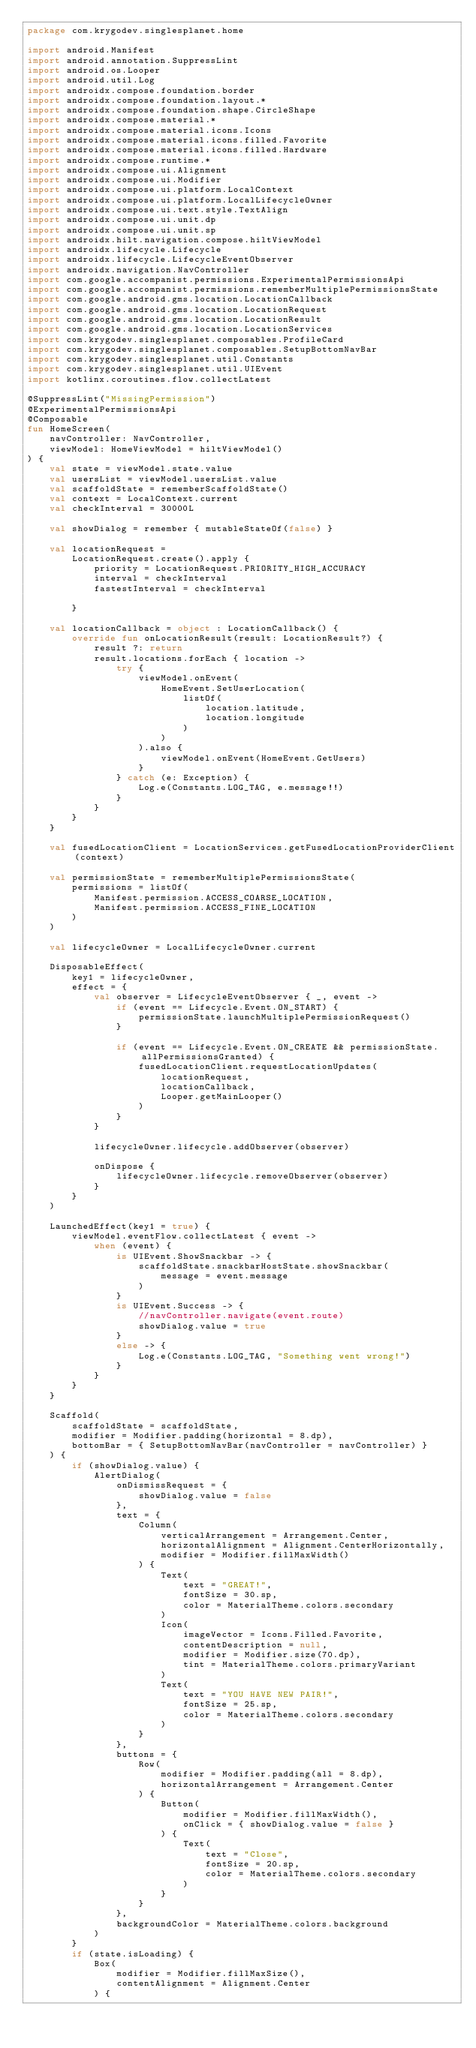Convert code to text. <code><loc_0><loc_0><loc_500><loc_500><_Kotlin_>package com.krygodev.singlesplanet.home

import android.Manifest
import android.annotation.SuppressLint
import android.os.Looper
import android.util.Log
import androidx.compose.foundation.border
import androidx.compose.foundation.layout.*
import androidx.compose.foundation.shape.CircleShape
import androidx.compose.material.*
import androidx.compose.material.icons.Icons
import androidx.compose.material.icons.filled.Favorite
import androidx.compose.material.icons.filled.Hardware
import androidx.compose.runtime.*
import androidx.compose.ui.Alignment
import androidx.compose.ui.Modifier
import androidx.compose.ui.platform.LocalContext
import androidx.compose.ui.platform.LocalLifecycleOwner
import androidx.compose.ui.text.style.TextAlign
import androidx.compose.ui.unit.dp
import androidx.compose.ui.unit.sp
import androidx.hilt.navigation.compose.hiltViewModel
import androidx.lifecycle.Lifecycle
import androidx.lifecycle.LifecycleEventObserver
import androidx.navigation.NavController
import com.google.accompanist.permissions.ExperimentalPermissionsApi
import com.google.accompanist.permissions.rememberMultiplePermissionsState
import com.google.android.gms.location.LocationCallback
import com.google.android.gms.location.LocationRequest
import com.google.android.gms.location.LocationResult
import com.google.android.gms.location.LocationServices
import com.krygodev.singlesplanet.composables.ProfileCard
import com.krygodev.singlesplanet.composables.SetupBottomNavBar
import com.krygodev.singlesplanet.util.Constants
import com.krygodev.singlesplanet.util.UIEvent
import kotlinx.coroutines.flow.collectLatest

@SuppressLint("MissingPermission")
@ExperimentalPermissionsApi
@Composable
fun HomeScreen(
    navController: NavController,
    viewModel: HomeViewModel = hiltViewModel()
) {
    val state = viewModel.state.value
    val usersList = viewModel.usersList.value
    val scaffoldState = rememberScaffoldState()
    val context = LocalContext.current
    val checkInterval = 30000L

    val showDialog = remember { mutableStateOf(false) }

    val locationRequest =
        LocationRequest.create().apply {
            priority = LocationRequest.PRIORITY_HIGH_ACCURACY
            interval = checkInterval
            fastestInterval = checkInterval

        }

    val locationCallback = object : LocationCallback() {
        override fun onLocationResult(result: LocationResult?) {
            result ?: return
            result.locations.forEach { location ->
                try {
                    viewModel.onEvent(
                        HomeEvent.SetUserLocation(
                            listOf(
                                location.latitude,
                                location.longitude
                            )
                        )
                    ).also {
                        viewModel.onEvent(HomeEvent.GetUsers)
                    }
                } catch (e: Exception) {
                    Log.e(Constants.LOG_TAG, e.message!!)
                }
            }
        }
    }

    val fusedLocationClient = LocationServices.getFusedLocationProviderClient(context)

    val permissionState = rememberMultiplePermissionsState(
        permissions = listOf(
            Manifest.permission.ACCESS_COARSE_LOCATION,
            Manifest.permission.ACCESS_FINE_LOCATION
        )
    )

    val lifecycleOwner = LocalLifecycleOwner.current

    DisposableEffect(
        key1 = lifecycleOwner,
        effect = {
            val observer = LifecycleEventObserver { _, event ->
                if (event == Lifecycle.Event.ON_START) {
                    permissionState.launchMultiplePermissionRequest()
                }

                if (event == Lifecycle.Event.ON_CREATE && permissionState.allPermissionsGranted) {
                    fusedLocationClient.requestLocationUpdates(
                        locationRequest,
                        locationCallback,
                        Looper.getMainLooper()
                    )
                }
            }

            lifecycleOwner.lifecycle.addObserver(observer)

            onDispose {
                lifecycleOwner.lifecycle.removeObserver(observer)
            }
        }
    )

    LaunchedEffect(key1 = true) {
        viewModel.eventFlow.collectLatest { event ->
            when (event) {
                is UIEvent.ShowSnackbar -> {
                    scaffoldState.snackbarHostState.showSnackbar(
                        message = event.message
                    )
                }
                is UIEvent.Success -> {
                    //navController.navigate(event.route)
                    showDialog.value = true
                }
                else -> {
                    Log.e(Constants.LOG_TAG, "Something went wrong!")
                }
            }
        }
    }

    Scaffold(
        scaffoldState = scaffoldState,
        modifier = Modifier.padding(horizontal = 8.dp),
        bottomBar = { SetupBottomNavBar(navController = navController) }
    ) {
        if (showDialog.value) {
            AlertDialog(
                onDismissRequest = {
                    showDialog.value = false
                },
                text = {
                    Column(
                        verticalArrangement = Arrangement.Center,
                        horizontalAlignment = Alignment.CenterHorizontally,
                        modifier = Modifier.fillMaxWidth()
                    ) {
                        Text(
                            text = "GREAT!",
                            fontSize = 30.sp,
                            color = MaterialTheme.colors.secondary
                        )
                        Icon(
                            imageVector = Icons.Filled.Favorite,
                            contentDescription = null,
                            modifier = Modifier.size(70.dp),
                            tint = MaterialTheme.colors.primaryVariant
                        )
                        Text(
                            text = "YOU HAVE NEW PAIR!",
                            fontSize = 25.sp,
                            color = MaterialTheme.colors.secondary
                        )
                    }
                },
                buttons = {
                    Row(
                        modifier = Modifier.padding(all = 8.dp),
                        horizontalArrangement = Arrangement.Center
                    ) {
                        Button(
                            modifier = Modifier.fillMaxWidth(),
                            onClick = { showDialog.value = false }
                        ) {
                            Text(
                                text = "Close",
                                fontSize = 20.sp,
                                color = MaterialTheme.colors.secondary
                            )
                        }
                    }
                },
                backgroundColor = MaterialTheme.colors.background
            )
        }
        if (state.isLoading) {
            Box(
                modifier = Modifier.fillMaxSize(),
                contentAlignment = Alignment.Center
            ) {</code> 